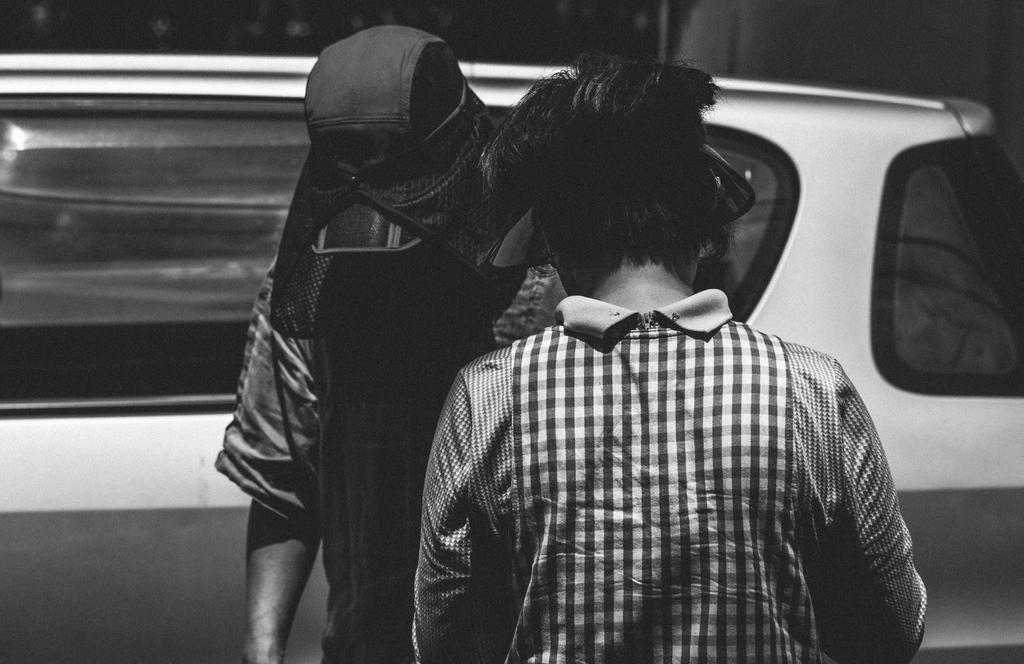How many people are visible in the image? There are two people in the front of the image. What is located in the back of the image? There is a car in the back of the image. What color scheme is used in the image? The image is black and white. What type of division can be seen between the two people in the image? There is no division between the two people in the image; they are standing close to each other. 